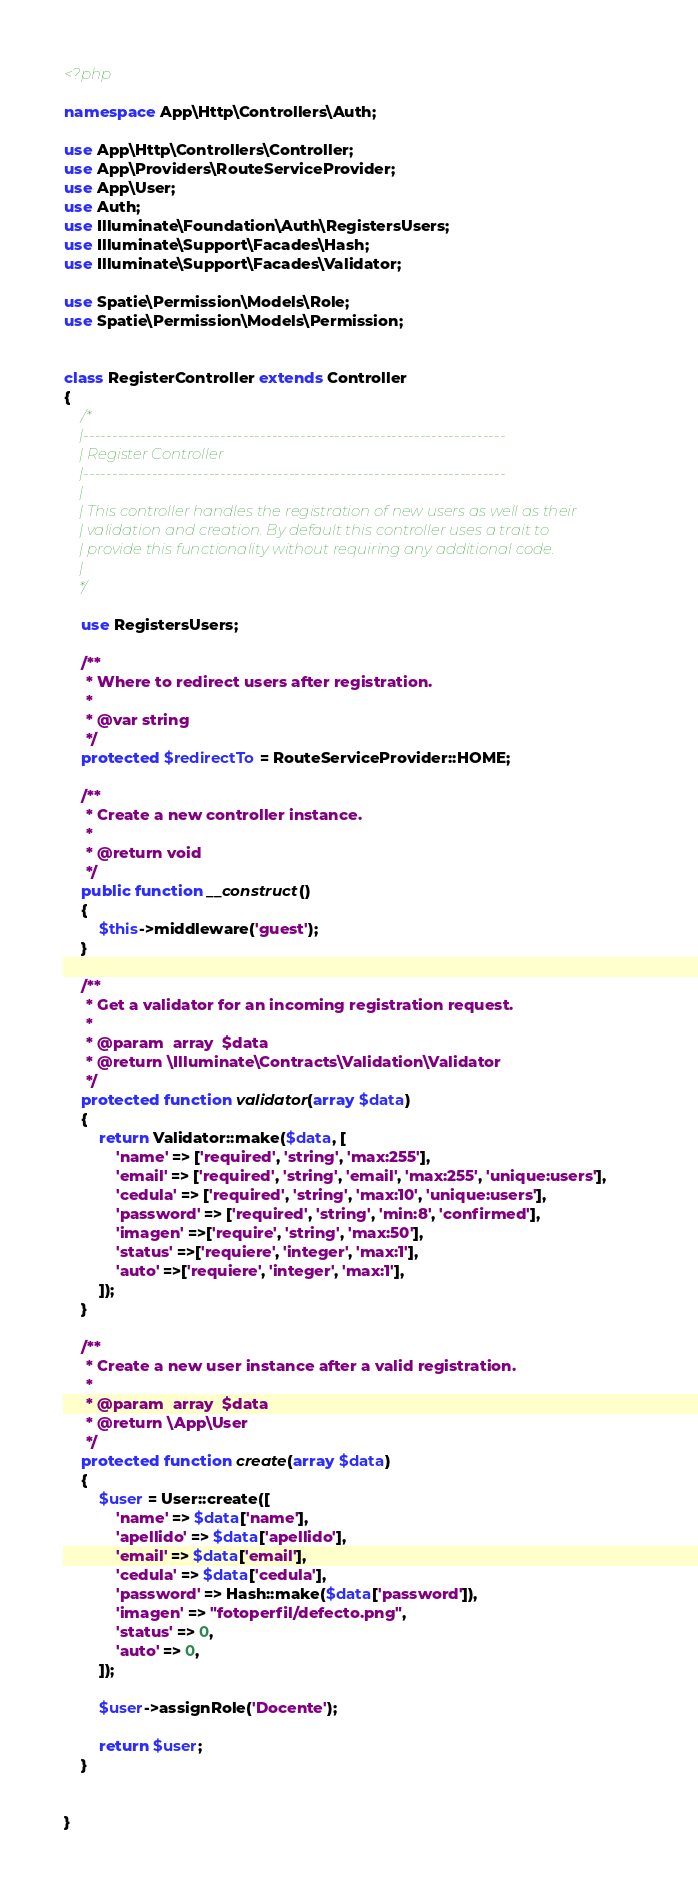<code> <loc_0><loc_0><loc_500><loc_500><_PHP_><?php

namespace App\Http\Controllers\Auth;

use App\Http\Controllers\Controller;
use App\Providers\RouteServiceProvider;
use App\User;
use Auth;
use Illuminate\Foundation\Auth\RegistersUsers;
use Illuminate\Support\Facades\Hash;
use Illuminate\Support\Facades\Validator;

use Spatie\Permission\Models\Role;
use Spatie\Permission\Models\Permission;


class RegisterController extends Controller
{
    /*
    |--------------------------------------------------------------------------
    | Register Controller
    |--------------------------------------------------------------------------
    |
    | This controller handles the registration of new users as well as their
    | validation and creation. By default this controller uses a trait to
    | provide this functionality without requiring any additional code.
    |
    */

    use RegistersUsers;

    /**
     * Where to redirect users after registration.
     *
     * @var string
     */
    protected $redirectTo = RouteServiceProvider::HOME;

    /**
     * Create a new controller instance.
     *
     * @return void
     */
    public function __construct()
    {
        $this->middleware('guest');
    }

    /**
     * Get a validator for an incoming registration request.
     *
     * @param  array  $data
     * @return \Illuminate\Contracts\Validation\Validator
     */
    protected function validator(array $data)
    {
        return Validator::make($data, [
            'name' => ['required', 'string', 'max:255'],
            'email' => ['required', 'string', 'email', 'max:255', 'unique:users'],
            'cedula' => ['required', 'string', 'max:10', 'unique:users'],
            'password' => ['required', 'string', 'min:8', 'confirmed'],
            'imagen' =>['require', 'string', 'max:50'],
            'status' =>['requiere', 'integer', 'max:1'],
            'auto' =>['requiere', 'integer', 'max:1'],
        ]);
    }

    /**
     * Create a new user instance after a valid registration.
     *
     * @param  array  $data
     * @return \App\User
     */
    protected function create(array $data)
    {
        $user = User::create([
            'name' => $data['name'],
            'apellido' => $data['apellido'],
            'email' => $data['email'],
            'cedula' => $data['cedula'],
            'password' => Hash::make($data['password']),
            'imagen' => "fotoperfil/defecto.png",
            'status' => 0,
            'auto' => 0,
        ]);
 
        $user->assignRole('Docente');

        return $user;
    }

    
}
</code> 